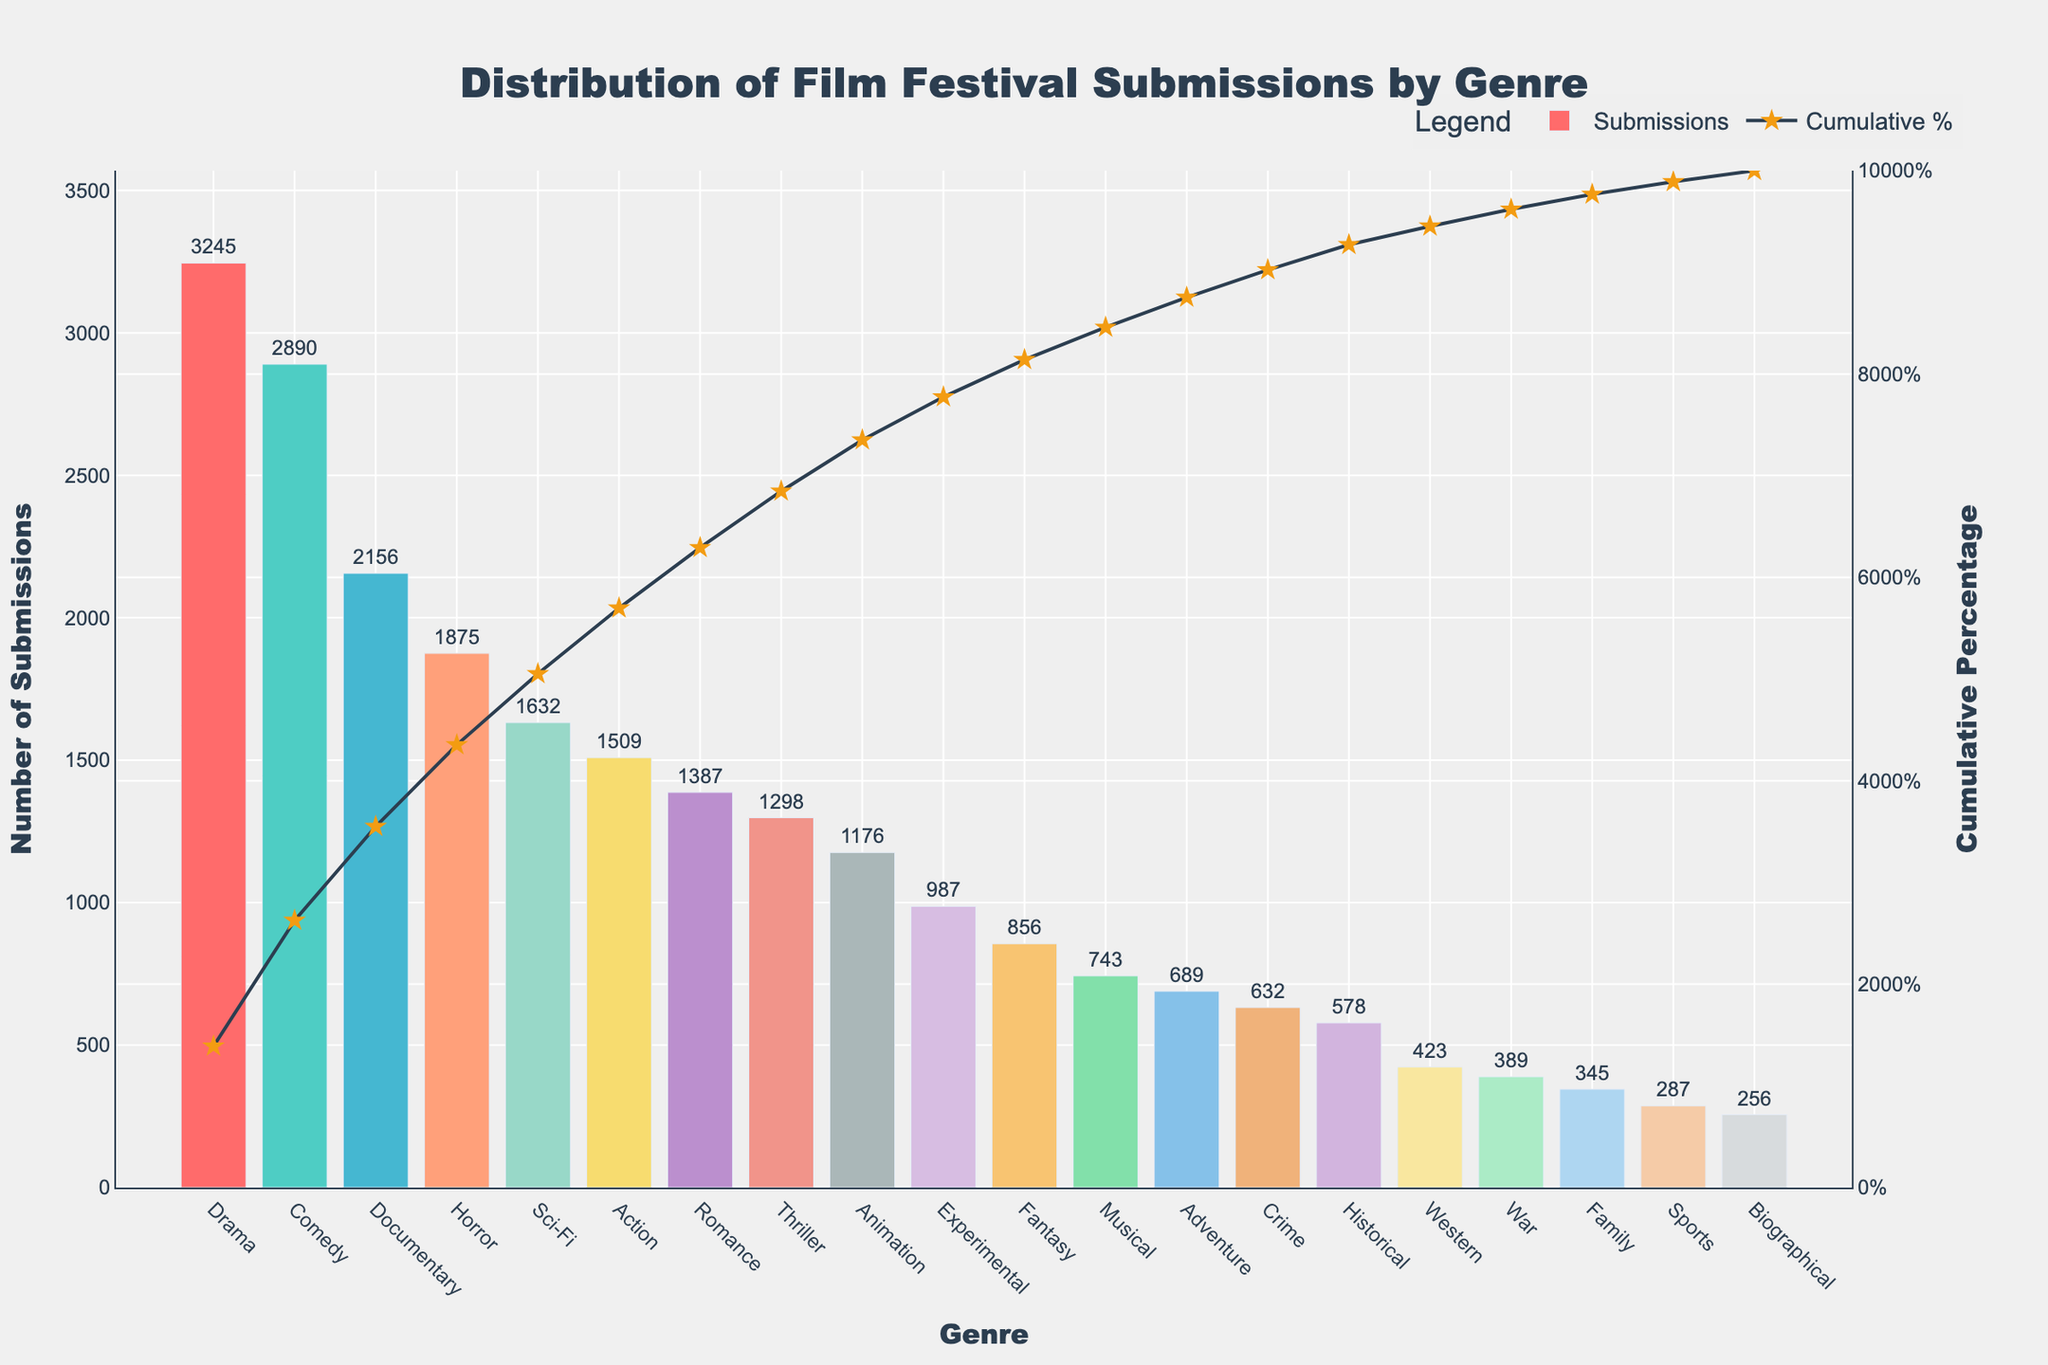Which genre has the highest number of submissions? The genre with the highest bar will be the one with the highest number of submissions. From the chart, the tallest bar is for Drama.
Answer: Drama What is the total number of submissions for Drama, Comedy, and Documentary genres? Sum the number of submissions for Drama (3245), Comedy (2890), and Documentary (2156). The total is 3245 + 2890 + 2156 = 8291.
Answer: 8291 By how much do Drama submissions exceed Horror submissions? Subtract the number of submissions for Horror (1875) from Drama (3245). The difference is 3245 - 1875 = 1370.
Answer: 1370 What is the difference in the cumulative percentage between Sci-Fi and Action submissions? Look at the cumulative percentages indicated for Sci-Fi and Action. Sci-Fi shows a cumulative percentage of around 76.4% while Action shows around 88.4%, so the difference is approximately 88.4% - 76.4% = 12%.
Answer: 12% How many submissions separate Animation and Experimental genres? Subtract the number of submissions for Experimental (987) from Animation (1176). The difference is 1176 - 987 = 189.
Answer: 189 What genre has the closest number of submissions to 1000? From the chart, Experimental has 987 submissions, which is closest to 1000.
Answer: Experimental Which genre appears just after Comedy in terms of submissions on the chart? The genre that comes after Comedy in the sorted list is Documentary with 2156 submissions.
Answer: Documentary What is the combined cumulative percentage up to Thriller submissions? Add the cumulative percentages up to Thriller. From Drama (19.7%), Comedy (~37.3%), Documentary (~51.4%), Horror (~62.8%), Sci-Fi (~71.8%), Action (~79.3%), Romance (~86.7%), and Thriller (~93.4%), the combined cumulative percentage is approximately 93.4%.
Answer: 93.4% What is the ratio of submissions between the highest and lowest submission genres? The highest is Drama (3245) and the lowest is Biographical (256). The ratio is 3245:256. Simplifying this gives approximately 12.68:1.
Answer: 12.68:1 